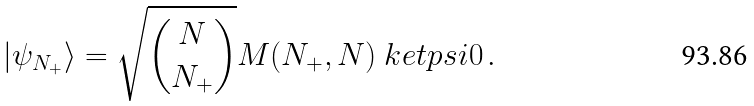<formula> <loc_0><loc_0><loc_500><loc_500>| \psi _ { N _ { + } } \rangle = \sqrt { { N \choose { N _ { + } } } } M ( N _ { + } , N ) \ k e t p s i { 0 } \, .</formula> 